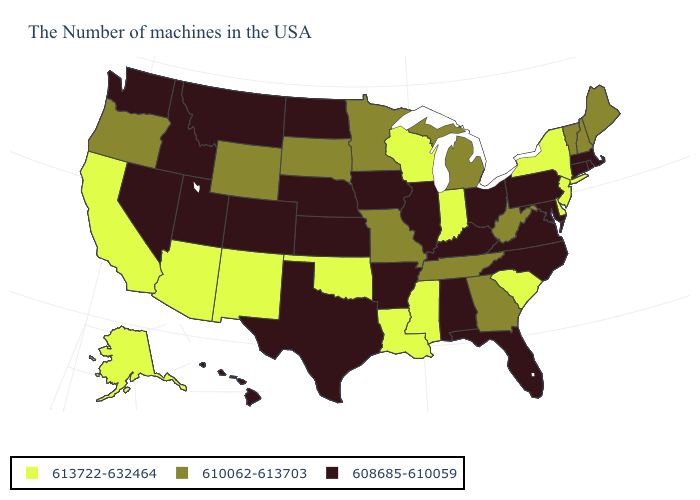What is the value of Alabama?
Answer briefly. 608685-610059. What is the value of South Carolina?
Write a very short answer. 613722-632464. What is the highest value in states that border Vermont?
Give a very brief answer. 613722-632464. What is the value of Wyoming?
Be succinct. 610062-613703. Which states hav the highest value in the South?
Keep it brief. Delaware, South Carolina, Mississippi, Louisiana, Oklahoma. Which states have the highest value in the USA?
Write a very short answer. New York, New Jersey, Delaware, South Carolina, Indiana, Wisconsin, Mississippi, Louisiana, Oklahoma, New Mexico, Arizona, California, Alaska. What is the highest value in states that border Wisconsin?
Quick response, please. 610062-613703. Does Minnesota have a higher value than Pennsylvania?
Write a very short answer. Yes. What is the value of Tennessee?
Answer briefly. 610062-613703. Does the map have missing data?
Be succinct. No. What is the highest value in the USA?
Write a very short answer. 613722-632464. Does New York have the highest value in the Northeast?
Answer briefly. Yes. What is the value of West Virginia?
Write a very short answer. 610062-613703. What is the lowest value in the USA?
Answer briefly. 608685-610059. Which states hav the highest value in the MidWest?
Write a very short answer. Indiana, Wisconsin. 